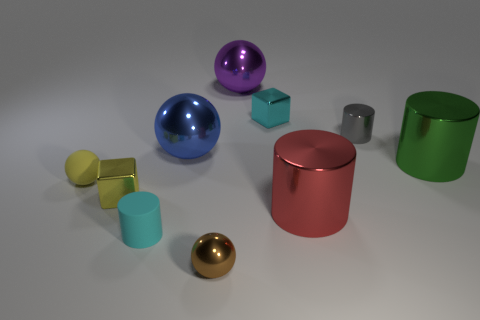Which object stands out the most due to its color? The blue sphere stands out due to its vibrant color and high reflectivity in contrast to the relatively muted colors of the other objects. 